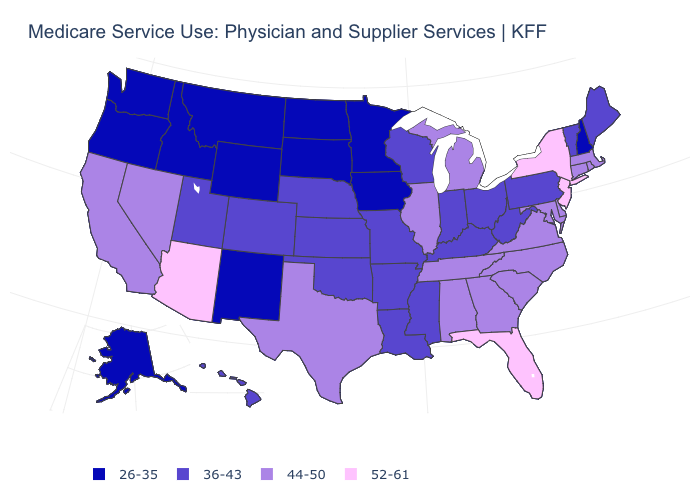What is the value of Ohio?
Short answer required. 36-43. What is the value of Wisconsin?
Be succinct. 36-43. Name the states that have a value in the range 36-43?
Concise answer only. Arkansas, Colorado, Hawaii, Indiana, Kansas, Kentucky, Louisiana, Maine, Mississippi, Missouri, Nebraska, Ohio, Oklahoma, Pennsylvania, Utah, Vermont, West Virginia, Wisconsin. Among the states that border Oklahoma , does New Mexico have the lowest value?
Short answer required. Yes. Name the states that have a value in the range 44-50?
Short answer required. Alabama, California, Connecticut, Delaware, Georgia, Illinois, Maryland, Massachusetts, Michigan, Nevada, North Carolina, Rhode Island, South Carolina, Tennessee, Texas, Virginia. Does the map have missing data?
Answer briefly. No. Among the states that border New Hampshire , which have the lowest value?
Write a very short answer. Maine, Vermont. What is the lowest value in the West?
Be succinct. 26-35. Does Arizona have the highest value in the USA?
Be succinct. Yes. What is the lowest value in the South?
Write a very short answer. 36-43. What is the highest value in states that border Missouri?
Keep it brief. 44-50. Name the states that have a value in the range 26-35?
Quick response, please. Alaska, Idaho, Iowa, Minnesota, Montana, New Hampshire, New Mexico, North Dakota, Oregon, South Dakota, Washington, Wyoming. What is the highest value in states that border Maryland?
Be succinct. 44-50. Name the states that have a value in the range 36-43?
Short answer required. Arkansas, Colorado, Hawaii, Indiana, Kansas, Kentucky, Louisiana, Maine, Mississippi, Missouri, Nebraska, Ohio, Oklahoma, Pennsylvania, Utah, Vermont, West Virginia, Wisconsin. Which states hav the highest value in the West?
Quick response, please. Arizona. 